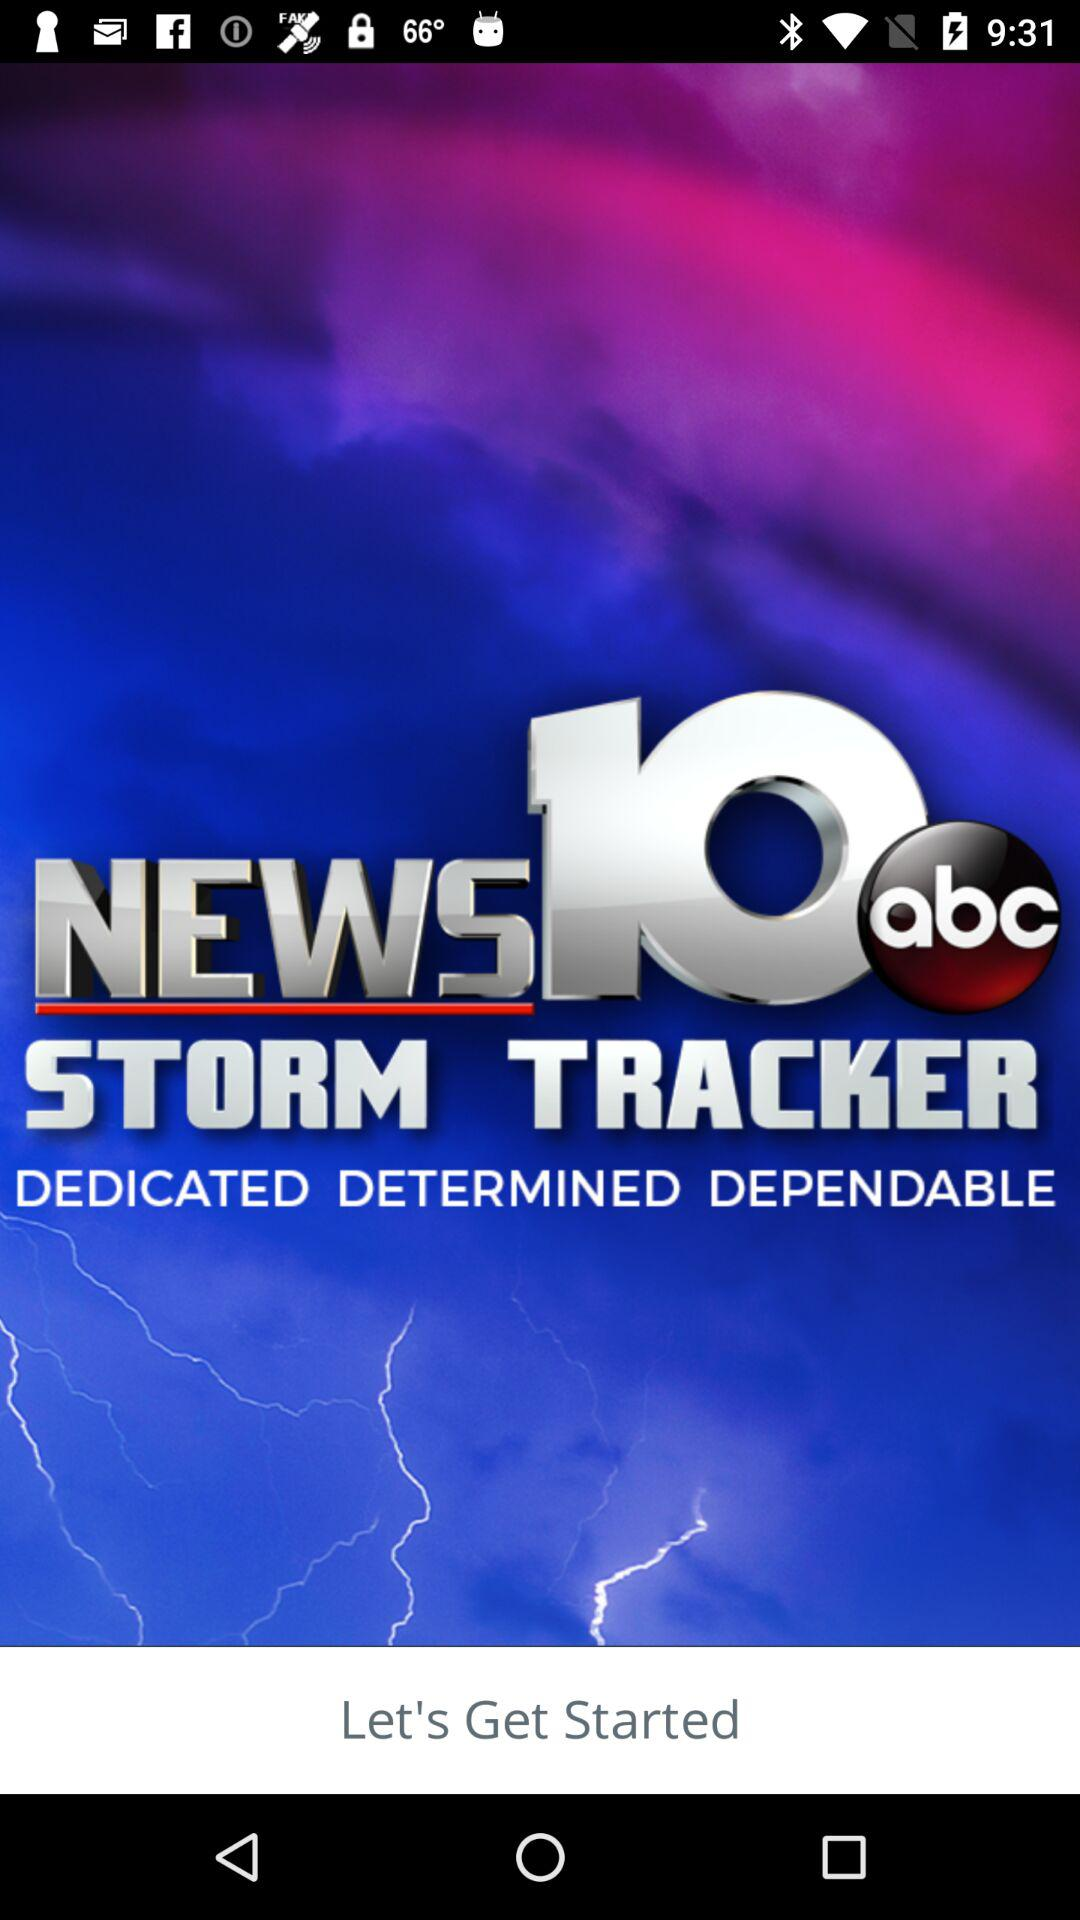What is the application name? The application name is "WTEN Storm Tracker - NEWS10". 